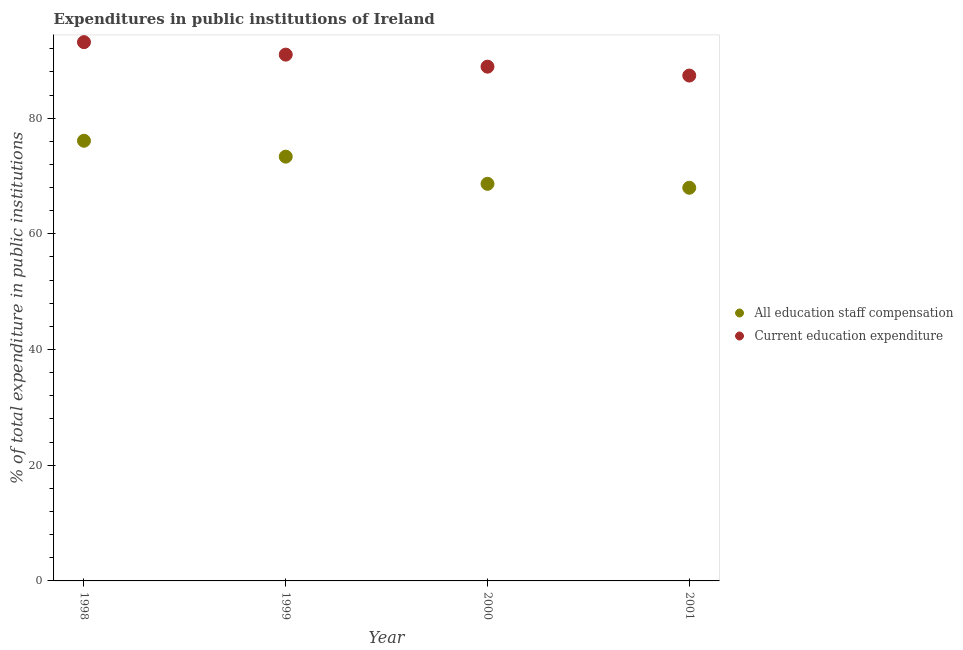Is the number of dotlines equal to the number of legend labels?
Provide a short and direct response. Yes. What is the expenditure in staff compensation in 2000?
Ensure brevity in your answer.  68.65. Across all years, what is the maximum expenditure in education?
Make the answer very short. 93.14. Across all years, what is the minimum expenditure in education?
Offer a very short reply. 87.36. What is the total expenditure in staff compensation in the graph?
Your response must be concise. 286.05. What is the difference between the expenditure in education in 1998 and that in 1999?
Offer a terse response. 2.15. What is the difference between the expenditure in staff compensation in 1999 and the expenditure in education in 1998?
Provide a succinct answer. -19.79. What is the average expenditure in education per year?
Your answer should be compact. 90.1. In the year 1999, what is the difference between the expenditure in education and expenditure in staff compensation?
Make the answer very short. 17.64. What is the ratio of the expenditure in education in 1998 to that in 1999?
Make the answer very short. 1.02. Is the expenditure in staff compensation in 1998 less than that in 1999?
Your answer should be very brief. No. What is the difference between the highest and the second highest expenditure in staff compensation?
Make the answer very short. 2.75. What is the difference between the highest and the lowest expenditure in staff compensation?
Make the answer very short. 8.13. Is the sum of the expenditure in staff compensation in 1998 and 2000 greater than the maximum expenditure in education across all years?
Give a very brief answer. Yes. How many dotlines are there?
Your answer should be very brief. 2. How many years are there in the graph?
Your answer should be compact. 4. What is the difference between two consecutive major ticks on the Y-axis?
Offer a very short reply. 20. Are the values on the major ticks of Y-axis written in scientific E-notation?
Offer a terse response. No. Does the graph contain any zero values?
Make the answer very short. No. Does the graph contain grids?
Make the answer very short. No. Where does the legend appear in the graph?
Keep it short and to the point. Center right. How many legend labels are there?
Your answer should be compact. 2. What is the title of the graph?
Offer a very short reply. Expenditures in public institutions of Ireland. Does "Exports of goods" appear as one of the legend labels in the graph?
Your answer should be compact. No. What is the label or title of the X-axis?
Your response must be concise. Year. What is the label or title of the Y-axis?
Your answer should be compact. % of total expenditure in public institutions. What is the % of total expenditure in public institutions of All education staff compensation in 1998?
Your answer should be compact. 76.09. What is the % of total expenditure in public institutions of Current education expenditure in 1998?
Keep it short and to the point. 93.14. What is the % of total expenditure in public institutions of All education staff compensation in 1999?
Your response must be concise. 73.35. What is the % of total expenditure in public institutions in Current education expenditure in 1999?
Offer a terse response. 90.98. What is the % of total expenditure in public institutions of All education staff compensation in 2000?
Offer a terse response. 68.65. What is the % of total expenditure in public institutions of Current education expenditure in 2000?
Offer a terse response. 88.9. What is the % of total expenditure in public institutions of All education staff compensation in 2001?
Your answer should be very brief. 67.97. What is the % of total expenditure in public institutions in Current education expenditure in 2001?
Your answer should be very brief. 87.36. Across all years, what is the maximum % of total expenditure in public institutions in All education staff compensation?
Your response must be concise. 76.09. Across all years, what is the maximum % of total expenditure in public institutions in Current education expenditure?
Your response must be concise. 93.14. Across all years, what is the minimum % of total expenditure in public institutions of All education staff compensation?
Offer a terse response. 67.97. Across all years, what is the minimum % of total expenditure in public institutions of Current education expenditure?
Keep it short and to the point. 87.36. What is the total % of total expenditure in public institutions of All education staff compensation in the graph?
Make the answer very short. 286.05. What is the total % of total expenditure in public institutions in Current education expenditure in the graph?
Provide a succinct answer. 360.39. What is the difference between the % of total expenditure in public institutions in All education staff compensation in 1998 and that in 1999?
Make the answer very short. 2.75. What is the difference between the % of total expenditure in public institutions of Current education expenditure in 1998 and that in 1999?
Provide a succinct answer. 2.15. What is the difference between the % of total expenditure in public institutions of All education staff compensation in 1998 and that in 2000?
Offer a terse response. 7.45. What is the difference between the % of total expenditure in public institutions in Current education expenditure in 1998 and that in 2000?
Offer a very short reply. 4.24. What is the difference between the % of total expenditure in public institutions of All education staff compensation in 1998 and that in 2001?
Offer a terse response. 8.13. What is the difference between the % of total expenditure in public institutions of Current education expenditure in 1998 and that in 2001?
Make the answer very short. 5.77. What is the difference between the % of total expenditure in public institutions of All education staff compensation in 1999 and that in 2000?
Ensure brevity in your answer.  4.7. What is the difference between the % of total expenditure in public institutions of Current education expenditure in 1999 and that in 2000?
Provide a short and direct response. 2.08. What is the difference between the % of total expenditure in public institutions of All education staff compensation in 1999 and that in 2001?
Keep it short and to the point. 5.38. What is the difference between the % of total expenditure in public institutions in Current education expenditure in 1999 and that in 2001?
Give a very brief answer. 3.62. What is the difference between the % of total expenditure in public institutions of All education staff compensation in 2000 and that in 2001?
Provide a succinct answer. 0.68. What is the difference between the % of total expenditure in public institutions of Current education expenditure in 2000 and that in 2001?
Your answer should be compact. 1.54. What is the difference between the % of total expenditure in public institutions of All education staff compensation in 1998 and the % of total expenditure in public institutions of Current education expenditure in 1999?
Offer a very short reply. -14.89. What is the difference between the % of total expenditure in public institutions of All education staff compensation in 1998 and the % of total expenditure in public institutions of Current education expenditure in 2000?
Provide a succinct answer. -12.81. What is the difference between the % of total expenditure in public institutions of All education staff compensation in 1998 and the % of total expenditure in public institutions of Current education expenditure in 2001?
Provide a short and direct response. -11.27. What is the difference between the % of total expenditure in public institutions of All education staff compensation in 1999 and the % of total expenditure in public institutions of Current education expenditure in 2000?
Your answer should be very brief. -15.55. What is the difference between the % of total expenditure in public institutions in All education staff compensation in 1999 and the % of total expenditure in public institutions in Current education expenditure in 2001?
Your answer should be very brief. -14.02. What is the difference between the % of total expenditure in public institutions of All education staff compensation in 2000 and the % of total expenditure in public institutions of Current education expenditure in 2001?
Offer a terse response. -18.72. What is the average % of total expenditure in public institutions in All education staff compensation per year?
Offer a terse response. 71.51. What is the average % of total expenditure in public institutions of Current education expenditure per year?
Make the answer very short. 90.1. In the year 1998, what is the difference between the % of total expenditure in public institutions of All education staff compensation and % of total expenditure in public institutions of Current education expenditure?
Make the answer very short. -17.04. In the year 1999, what is the difference between the % of total expenditure in public institutions of All education staff compensation and % of total expenditure in public institutions of Current education expenditure?
Give a very brief answer. -17.64. In the year 2000, what is the difference between the % of total expenditure in public institutions of All education staff compensation and % of total expenditure in public institutions of Current education expenditure?
Keep it short and to the point. -20.25. In the year 2001, what is the difference between the % of total expenditure in public institutions of All education staff compensation and % of total expenditure in public institutions of Current education expenditure?
Your answer should be very brief. -19.4. What is the ratio of the % of total expenditure in public institutions in All education staff compensation in 1998 to that in 1999?
Provide a succinct answer. 1.04. What is the ratio of the % of total expenditure in public institutions of Current education expenditure in 1998 to that in 1999?
Keep it short and to the point. 1.02. What is the ratio of the % of total expenditure in public institutions of All education staff compensation in 1998 to that in 2000?
Your answer should be compact. 1.11. What is the ratio of the % of total expenditure in public institutions of Current education expenditure in 1998 to that in 2000?
Your response must be concise. 1.05. What is the ratio of the % of total expenditure in public institutions of All education staff compensation in 1998 to that in 2001?
Provide a short and direct response. 1.12. What is the ratio of the % of total expenditure in public institutions of Current education expenditure in 1998 to that in 2001?
Provide a short and direct response. 1.07. What is the ratio of the % of total expenditure in public institutions in All education staff compensation in 1999 to that in 2000?
Your answer should be compact. 1.07. What is the ratio of the % of total expenditure in public institutions in Current education expenditure in 1999 to that in 2000?
Provide a succinct answer. 1.02. What is the ratio of the % of total expenditure in public institutions in All education staff compensation in 1999 to that in 2001?
Your response must be concise. 1.08. What is the ratio of the % of total expenditure in public institutions of Current education expenditure in 1999 to that in 2001?
Provide a short and direct response. 1.04. What is the ratio of the % of total expenditure in public institutions of All education staff compensation in 2000 to that in 2001?
Offer a terse response. 1.01. What is the ratio of the % of total expenditure in public institutions of Current education expenditure in 2000 to that in 2001?
Provide a short and direct response. 1.02. What is the difference between the highest and the second highest % of total expenditure in public institutions of All education staff compensation?
Offer a very short reply. 2.75. What is the difference between the highest and the second highest % of total expenditure in public institutions of Current education expenditure?
Ensure brevity in your answer.  2.15. What is the difference between the highest and the lowest % of total expenditure in public institutions of All education staff compensation?
Ensure brevity in your answer.  8.13. What is the difference between the highest and the lowest % of total expenditure in public institutions in Current education expenditure?
Ensure brevity in your answer.  5.77. 